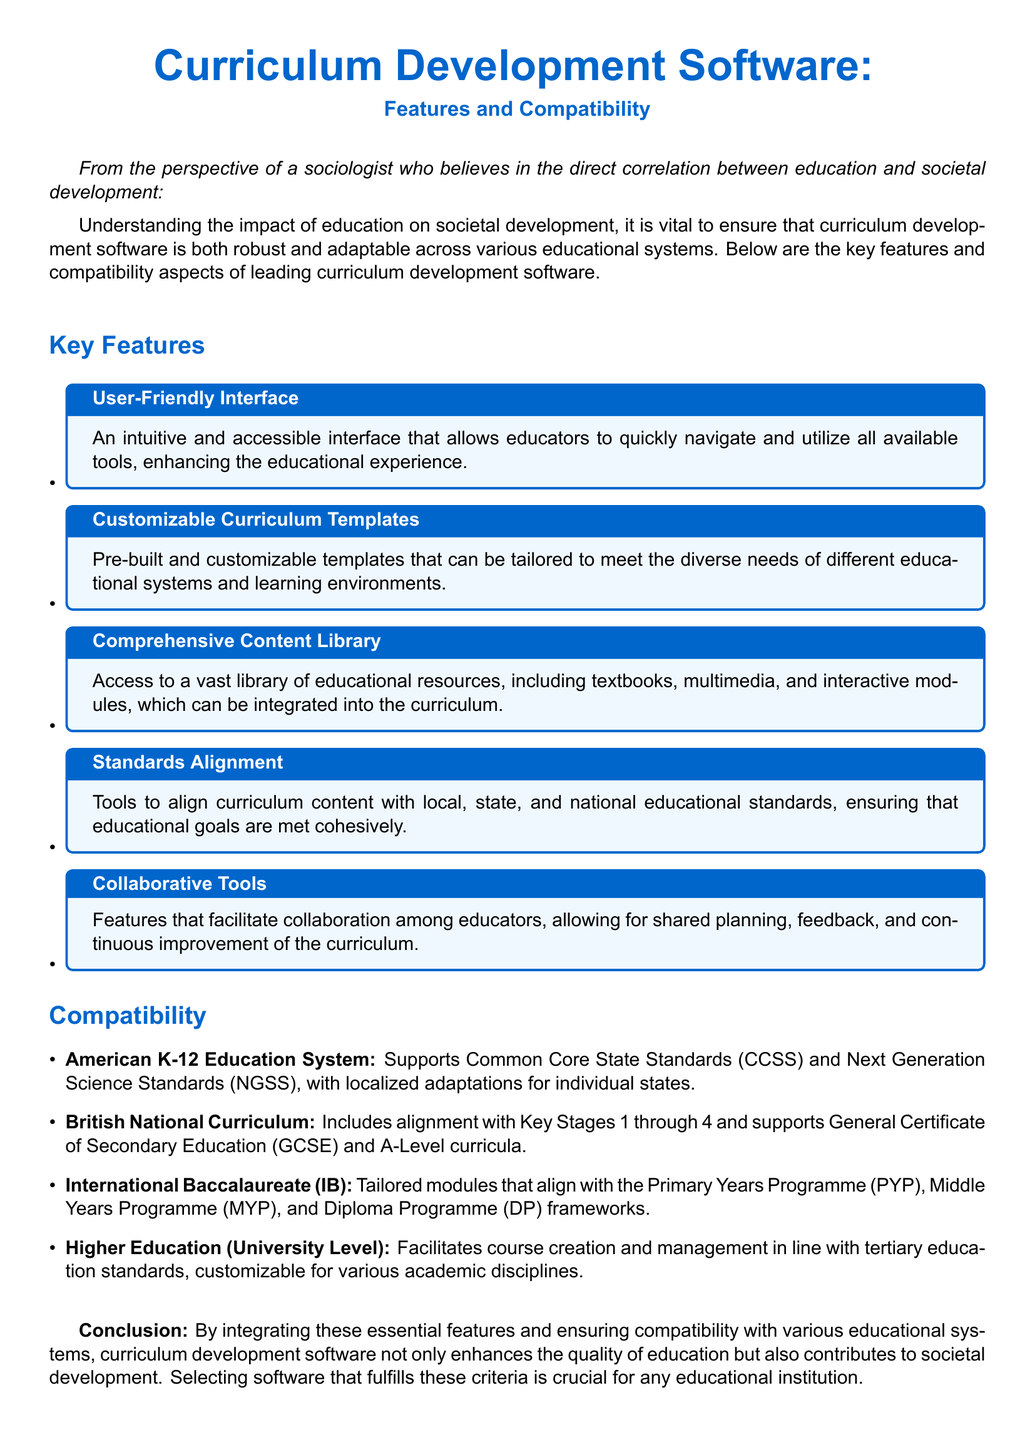What are the key features of the software? The key features are listed in the section titled "Key Features" of the document.
Answer: User-Friendly Interface, Customizable Curriculum Templates, Comprehensive Content Library, Standards Alignment, Collaborative Tools Which American education standards does the software support? The software's compatibility with American K-12 education standards is detailed in the Compatibility section.
Answer: Common Core State Standards, Next Generation Science Standards How many educational systems are mentioned for compatibility? The Compatibility section outlines various educational systems. Counting these provides the total.
Answer: Four What is the software’s alignment with the British National Curriculum? The document mentions how the software aligns with the British National Curriculum in the Compatibility section.
Answer: Key Stages 1 through 4, GCSE, A-Level What is the primary focus of this product specification sheet? The introduction specifies the document's aim regarding curriculum development software.
Answer: Features and Compatibility Do the features enable collaboration among educators? The features listed in the document provide details on whether collaboration is included.
Answer: Yes Which educational program does the software tailor modules for in the International Baccalaureate system? The Compatibility section details the specific IB frameworks the software addresses.
Answer: Primary Years Programme, Middle Years Programme, Diploma Programme What is the conclusion drawn about the software’s role in education? The last section summarizes the document's findings regarding the software's impact.
Answer: Enhances the quality of education, contributes to societal development 